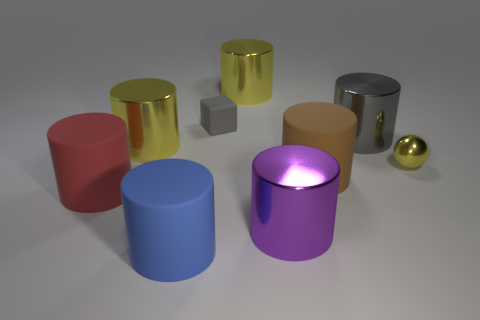There is a large thing that is the same color as the tiny rubber block; what is its shape?
Give a very brief answer. Cylinder. What color is the big shiny cylinder that is in front of the brown matte object?
Your answer should be very brief. Purple. What number of objects are either large metal cylinders in front of the tiny metal ball or large gray cylinders?
Your answer should be very brief. 2. What is the color of the ball that is the same size as the gray matte thing?
Ensure brevity in your answer.  Yellow. Is the number of small shiny spheres behind the small yellow metallic sphere greater than the number of large yellow metallic objects?
Provide a short and direct response. No. What is the material of the yellow object that is to the right of the gray matte thing and on the left side of the ball?
Provide a succinct answer. Metal. Is the color of the tiny metallic ball behind the large red matte cylinder the same as the big metal thing in front of the tiny ball?
Your response must be concise. No. How many other objects are the same size as the red cylinder?
Make the answer very short. 6. Are there any gray things in front of the matte cylinder on the right side of the rubber thing behind the metallic sphere?
Ensure brevity in your answer.  No. Does the large yellow object to the right of the small matte object have the same material as the big gray cylinder?
Make the answer very short. Yes. 